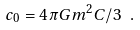Convert formula to latex. <formula><loc_0><loc_0><loc_500><loc_500>c _ { 0 } = 4 \pi G m ^ { 2 } C / 3 \ .</formula> 